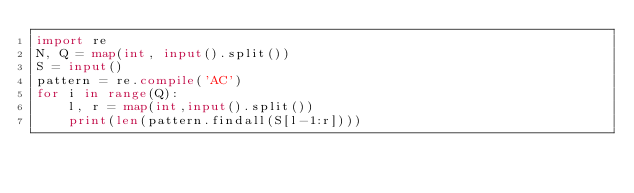<code> <loc_0><loc_0><loc_500><loc_500><_Python_>import re
N, Q = map(int, input().split())
S = input()
pattern = re.compile('AC')
for i in range(Q):
    l, r = map(int,input().split())
    print(len(pattern.findall(S[l-1:r])))</code> 